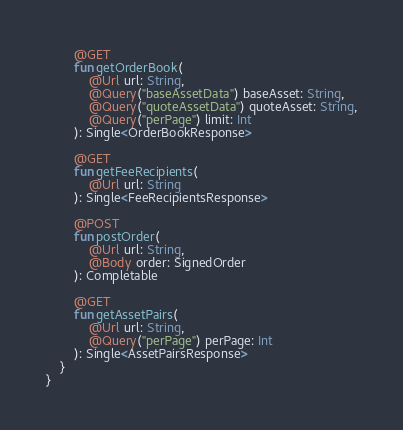Convert code to text. <code><loc_0><loc_0><loc_500><loc_500><_Kotlin_>        @GET
        fun getOrderBook(
            @Url url: String,
            @Query("baseAssetData") baseAsset: String,
            @Query("quoteAssetData") quoteAsset: String,
            @Query("perPage") limit: Int
        ): Single<OrderBookResponse>

        @GET
        fun getFeeRecipients(
            @Url url: String
        ): Single<FeeRecipientsResponse>

        @POST
        fun postOrder(
            @Url url: String,
            @Body order: SignedOrder
        ): Completable

        @GET
        fun getAssetPairs(
            @Url url: String,
            @Query("perPage") perPage: Int
        ): Single<AssetPairsResponse>
    }
}
</code> 